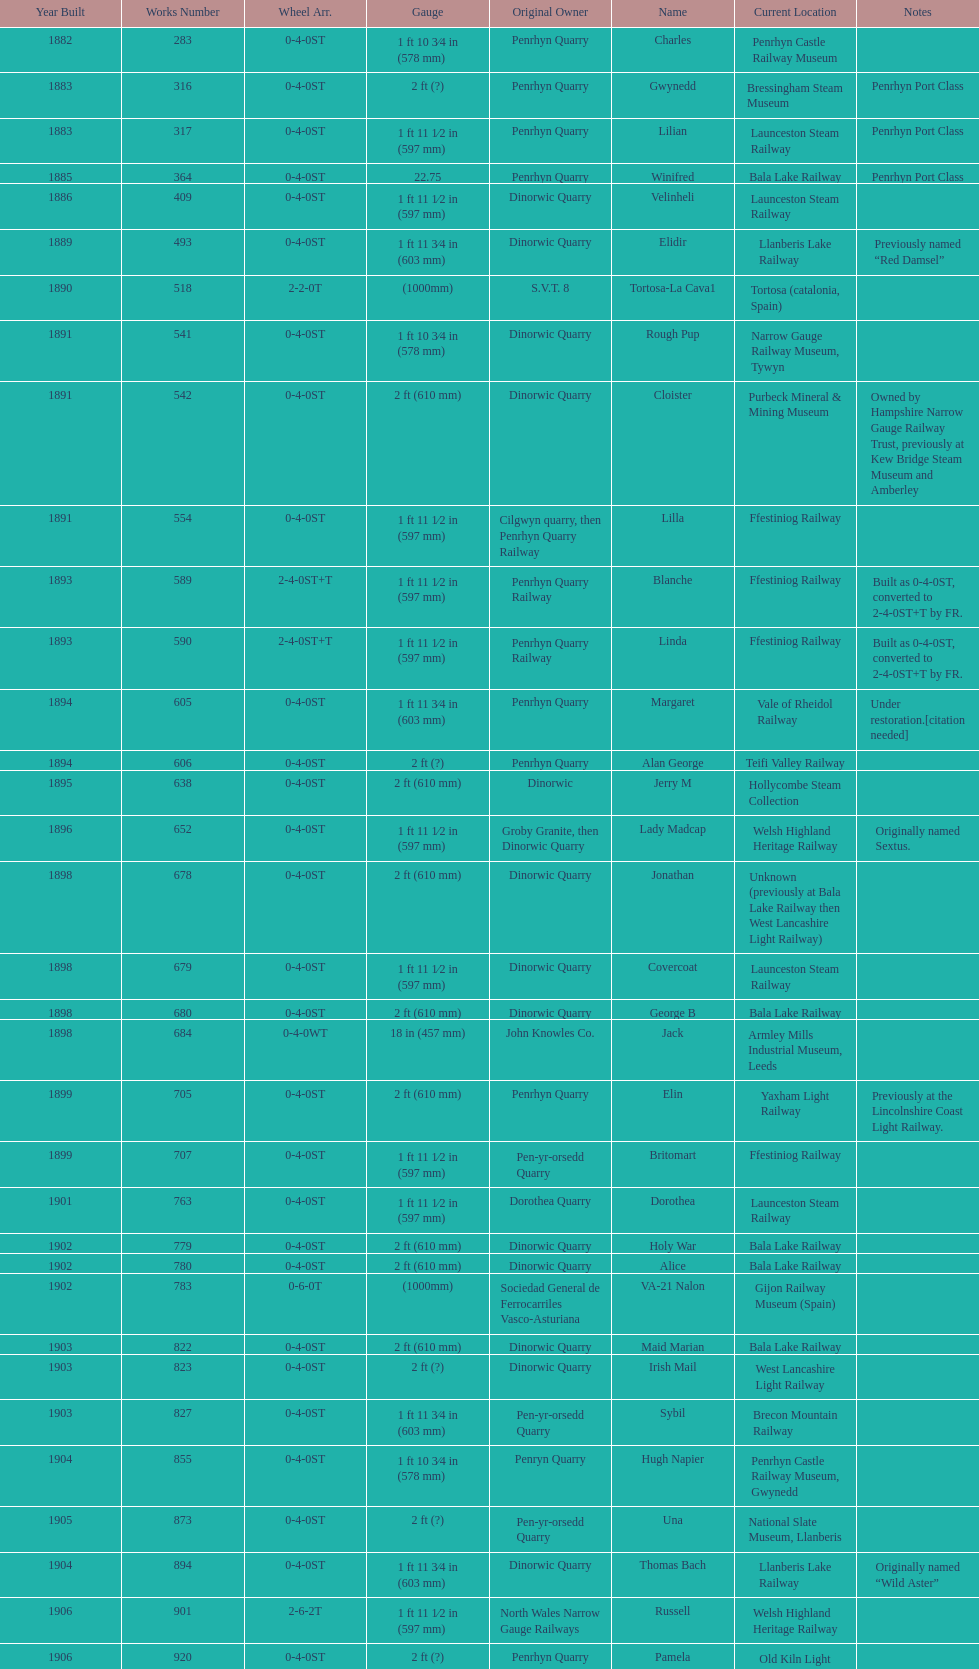In what way does the gauge vary between works numbers 541 and 542? 32 mm. 